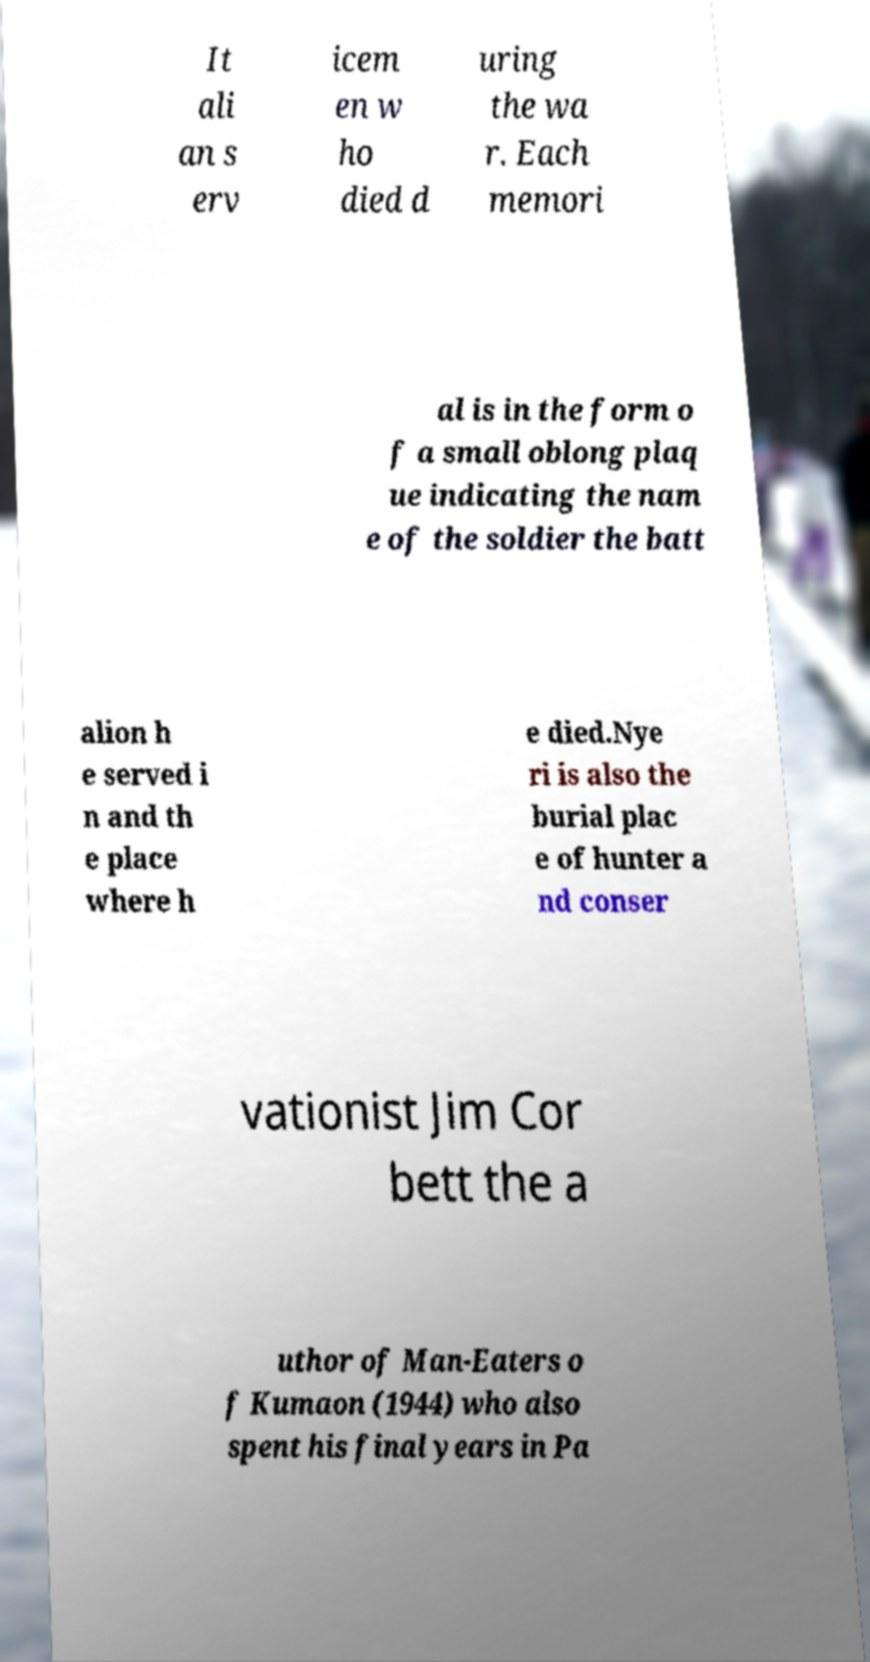Can you read and provide the text displayed in the image?This photo seems to have some interesting text. Can you extract and type it out for me? It ali an s erv icem en w ho died d uring the wa r. Each memori al is in the form o f a small oblong plaq ue indicating the nam e of the soldier the batt alion h e served i n and th e place where h e died.Nye ri is also the burial plac e of hunter a nd conser vationist Jim Cor bett the a uthor of Man-Eaters o f Kumaon (1944) who also spent his final years in Pa 